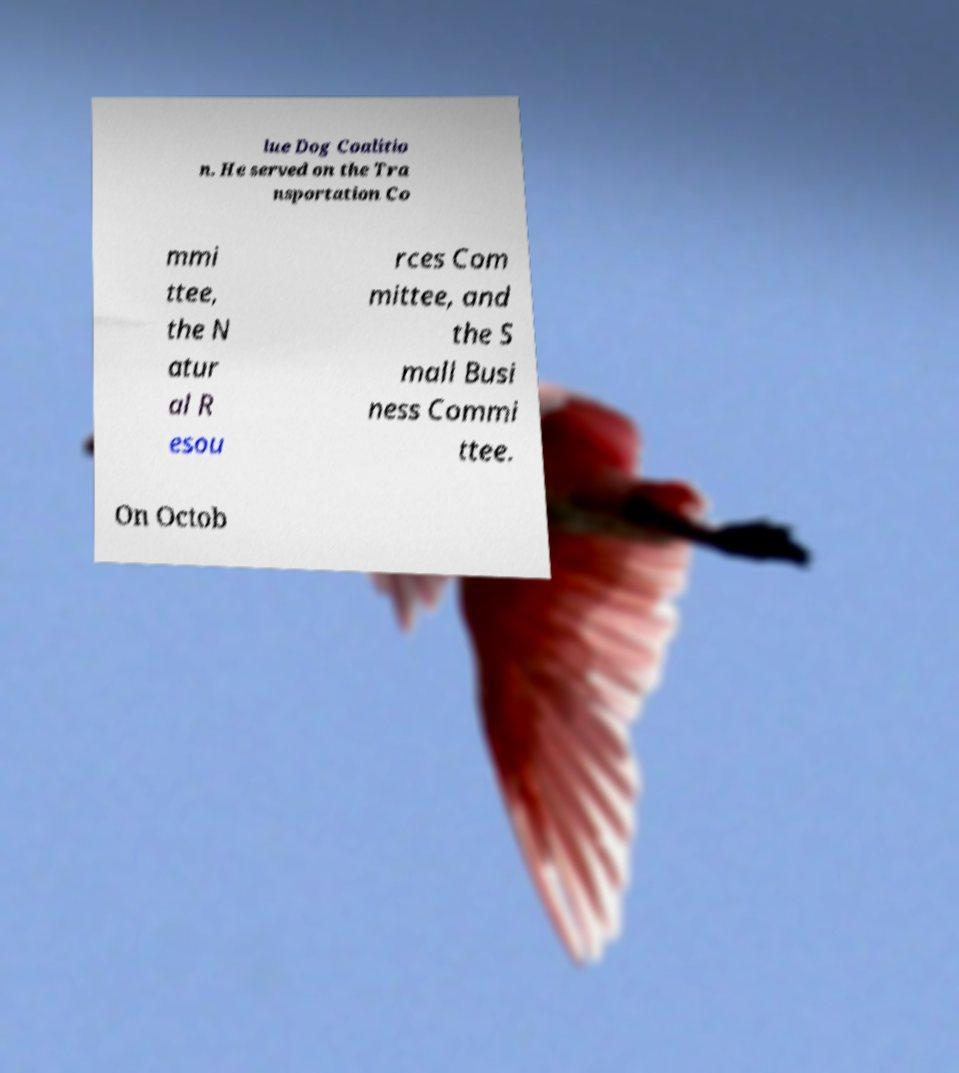There's text embedded in this image that I need extracted. Can you transcribe it verbatim? lue Dog Coalitio n. He served on the Tra nsportation Co mmi ttee, the N atur al R esou rces Com mittee, and the S mall Busi ness Commi ttee. On Octob 